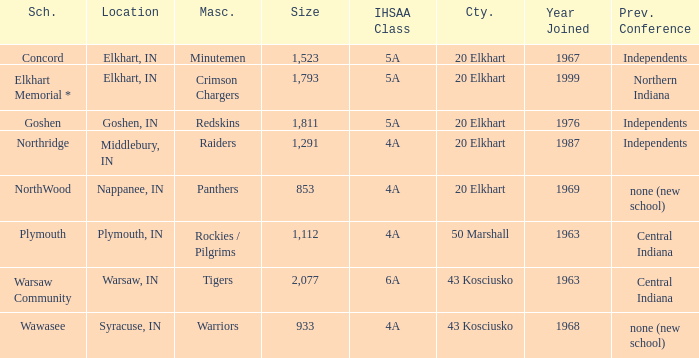What is the size of the team that was previously from Central Indiana conference, and is in IHSSA Class 4a? 1112.0. 